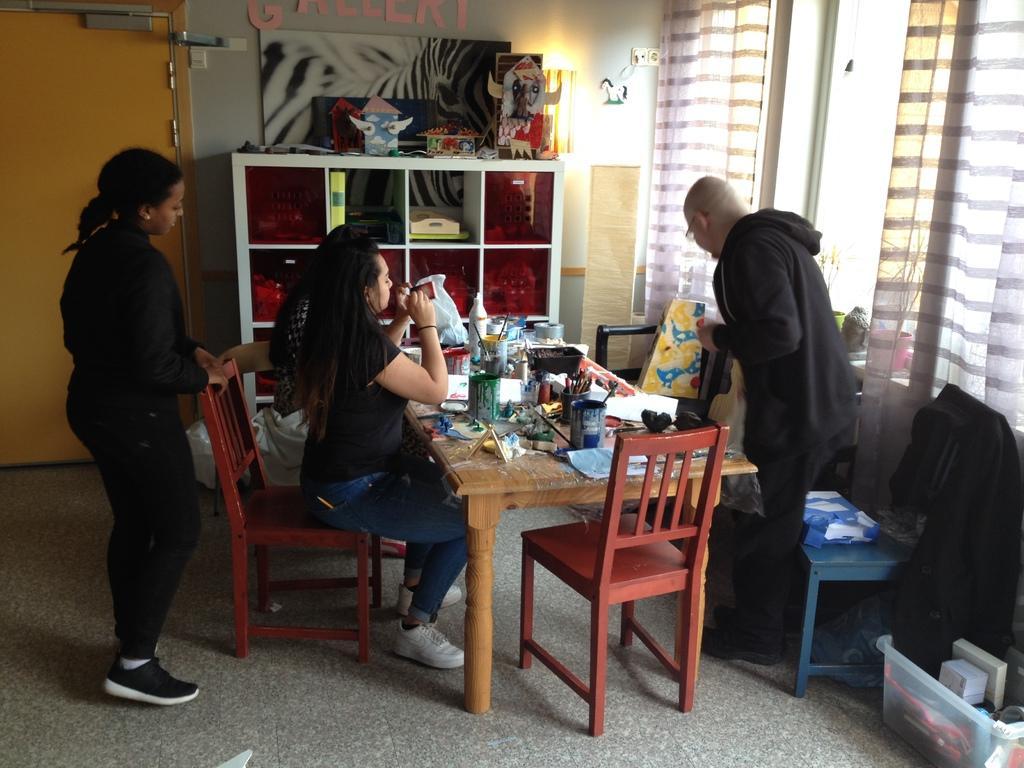Could you give a brief overview of what you see in this image? This is a picture in a room, in this picture there are a two of people who are sitting on a chair and two who standing on the floor. In front of this three people there is a table on the table there is a painting box, paints bottles. Backside of this people there is a shelf and a wall and a yellow color window. 